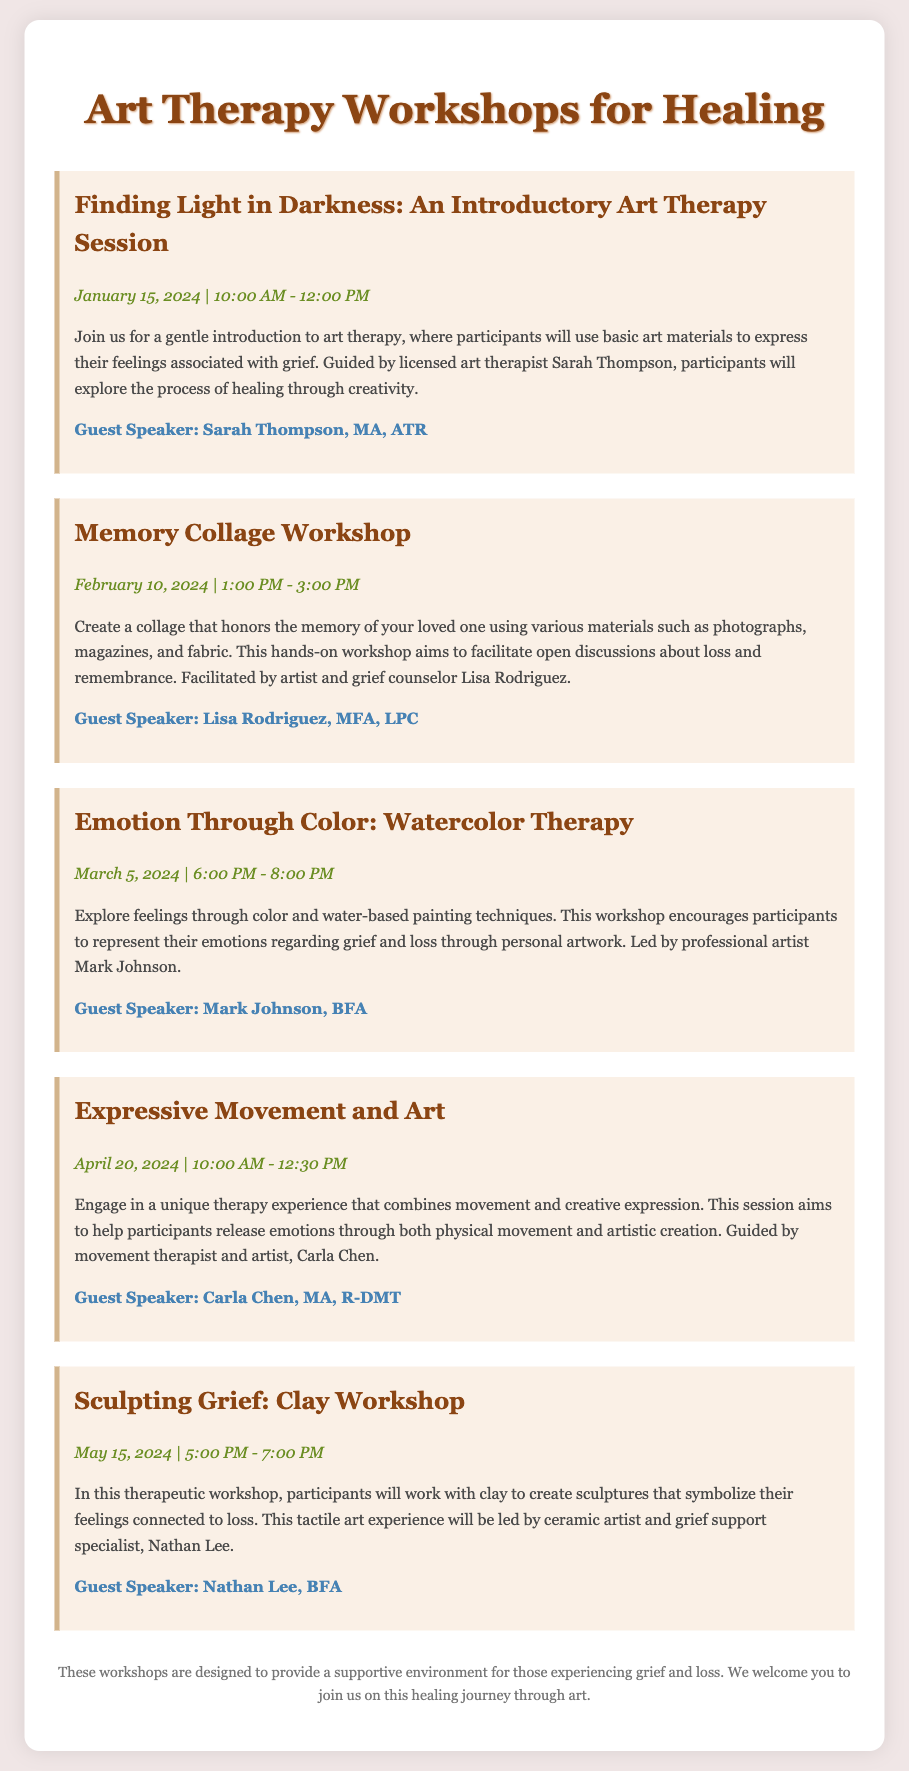What is the title of the first workshop? The title of the first workshop is explicitly mentioned at the beginning of the workshop section.
Answer: Finding Light in Darkness: An Introductory Art Therapy Session Who is the guest speaker for the Memory Collage Workshop? The guest speaker for the Memory Collage Workshop is listed directly below the workshop description.
Answer: Lisa Rodriguez, MFA, LPC What date is the Sculpting Grief workshop scheduled for? The date can be found in the date-time section of the corresponding workshop.
Answer: May 15, 2024 How long is the Emotion Through Color workshop? The duration is indicated alongside the time in the date-time section.
Answer: 2 hours Which workshop focuses on movement and creative expression? The description of the workshop provides context about its focus, and the title explicitly confirms it.
Answer: Expressive Movement and Art What is the first activity participants will do in the Finding Light in Darkness workshop? The initial activity related to the workshop is described in the first few sentences of its description.
Answer: Use basic art materials to express their feelings Who is facilitating the Clay Workshop? The facilitator is named in the description of the workshop, providing information about their qualifications and role.
Answer: Nathan Lee, BFA What time does the Emotion Through Color workshop start? The time can be found in the date-time section of the workshop details.
Answer: 6:00 PM What is the main aim of the workshops listed? The document describes the overall purpose of the workshops in the footer section.
Answer: Provide a supportive environment for those experiencing grief and loss 